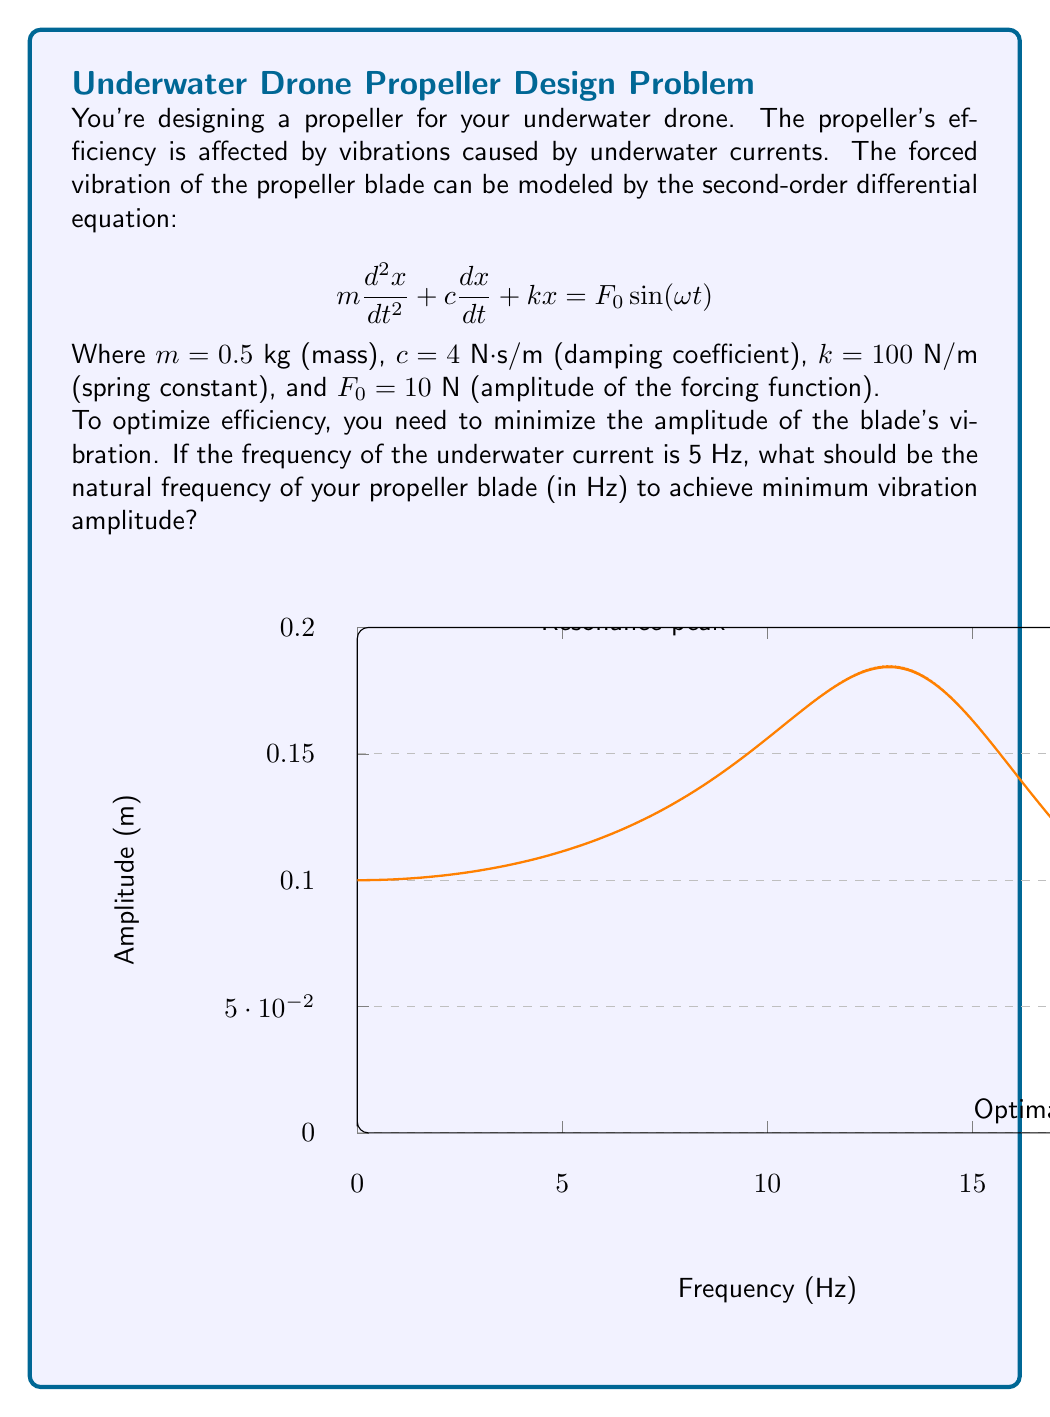Solve this math problem. Let's approach this step-by-step:

1) The natural frequency of the system is given by:

   $$\omega_n = \sqrt{\frac{k}{m}} = \sqrt{\frac{100}{0.5}} = 10\sqrt{2} \approx 14.14 \text{ rad/s}$$

2) The forcing frequency is given as 5 Hz. We need to convert this to rad/s:

   $$\omega = 2\pi f = 2\pi(5) = 10\pi \approx 31.42 \text{ rad/s}$$

3) For a second-order system, the amplitude of the steady-state response is given by:

   $$X = \frac{F_0/k}{\sqrt{(1-r^2)^2 + (2\zeta r)^2}}$$

   Where $r = \frac{\omega}{\omega_n}$ and $\zeta = \frac{c}{2\sqrt{km}}$ (damping ratio)

4) To minimize the amplitude, we need to maximize the denominator. This occurs when $\omega \gg \omega_n$, i.e., when $r$ is large.

5) In this case, we want $\omega$ (the forcing frequency) to be much larger than $\omega_n$ (the natural frequency of the propeller).

6) Given that $\omega \approx 31.42 \text{ rad/s}$, we should choose $\omega_n$ to be significantly smaller than this.

7) The natural frequency we calculated in step 1 ($14.14 \text{ rad/s}$) satisfies this condition.

8) Converting back to Hz:

   $$f_n = \frac{\omega_n}{2\pi} = \frac{14.14}{2\pi} \approx 2.25 \text{ Hz}$$

Therefore, to minimize vibration amplitude, the natural frequency of the propeller blade should be approximately 2.25 Hz.
Answer: 2.25 Hz 